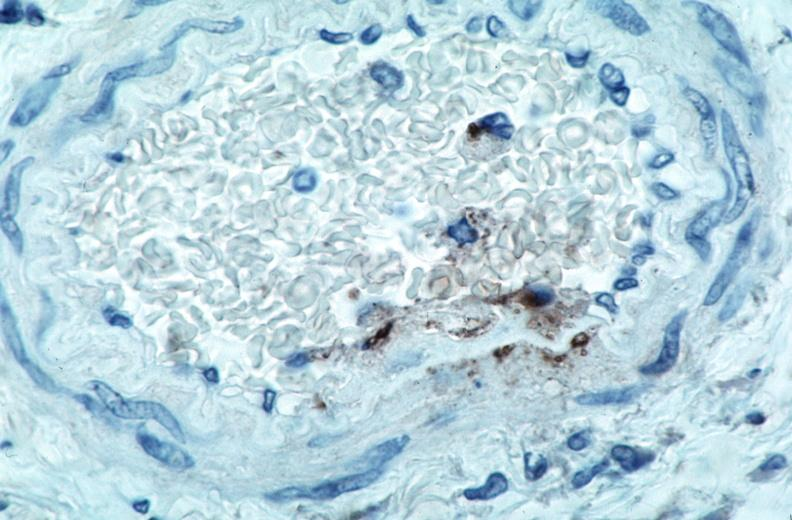what is present?
Answer the question using a single word or phrase. Cardiovascular 